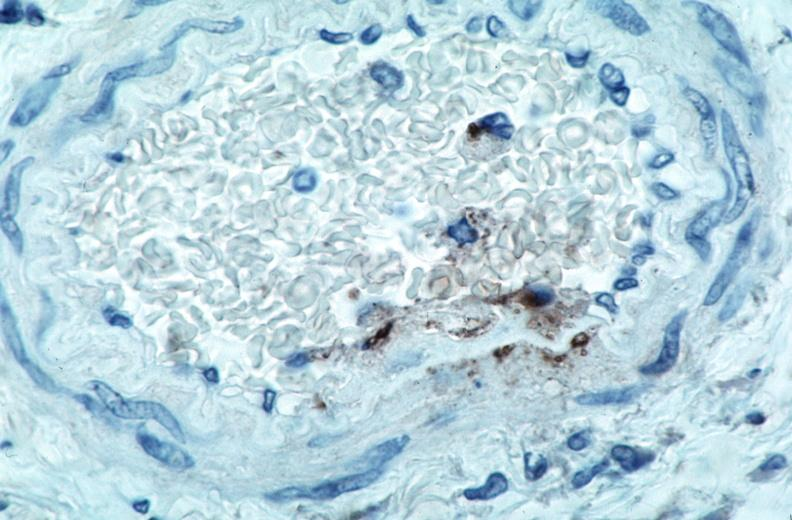what is present?
Answer the question using a single word or phrase. Cardiovascular 